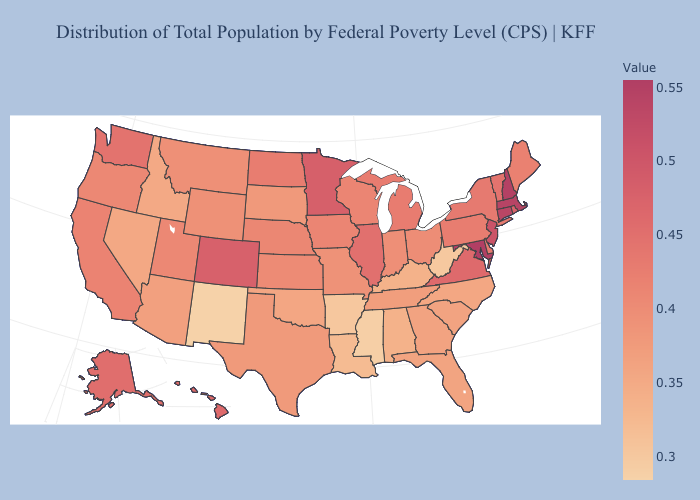Among the states that border Colorado , which have the lowest value?
Short answer required. New Mexico. Does Maine have the lowest value in the Northeast?
Answer briefly. Yes. Among the states that border Vermont , does New York have the lowest value?
Answer briefly. Yes. Does the map have missing data?
Answer briefly. No. Does the map have missing data?
Answer briefly. No. Among the states that border Arkansas , which have the lowest value?
Short answer required. Mississippi. 